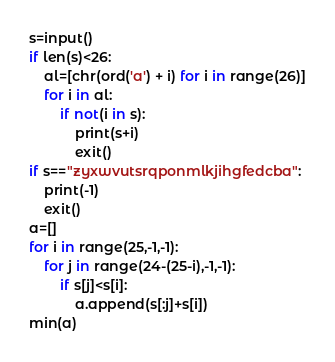Convert code to text. <code><loc_0><loc_0><loc_500><loc_500><_Python_>s=input()
if len(s)<26:
    al=[chr(ord('a') + i) for i in range(26)]
    for i in al:
        if not(i in s):
            print(s+i)
            exit()
if s=="zyxwvutsrqponmlkjihgfedcba":
    print(-1)
    exit()
a=[]
for i in range(25,-1,-1):
    for j in range(24-(25-i),-1,-1):
        if s[j]<s[i]:
            a.append(s[:j]+s[i])
min(a)</code> 